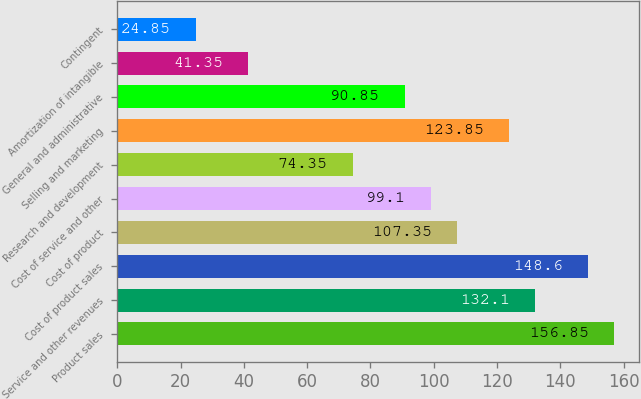<chart> <loc_0><loc_0><loc_500><loc_500><bar_chart><fcel>Product sales<fcel>Service and other revenues<fcel>Cost of product sales<fcel>Cost of product<fcel>Cost of service and other<fcel>Research and development<fcel>Selling and marketing<fcel>General and administrative<fcel>Amortization of intangible<fcel>Contingent<nl><fcel>156.85<fcel>132.1<fcel>148.6<fcel>107.35<fcel>99.1<fcel>74.35<fcel>123.85<fcel>90.85<fcel>41.35<fcel>24.85<nl></chart> 